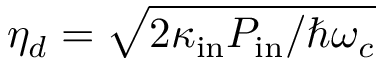<formula> <loc_0><loc_0><loc_500><loc_500>\eta _ { d } = \sqrt { 2 \kappa _ { i n } P _ { i n } / \hbar { \omega } _ { c } }</formula> 